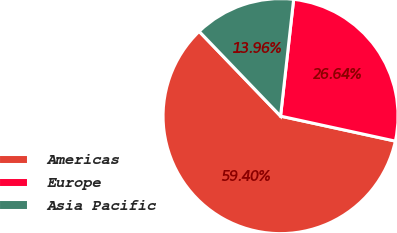<chart> <loc_0><loc_0><loc_500><loc_500><pie_chart><fcel>Americas<fcel>Europe<fcel>Asia Pacific<nl><fcel>59.41%<fcel>26.64%<fcel>13.96%<nl></chart> 